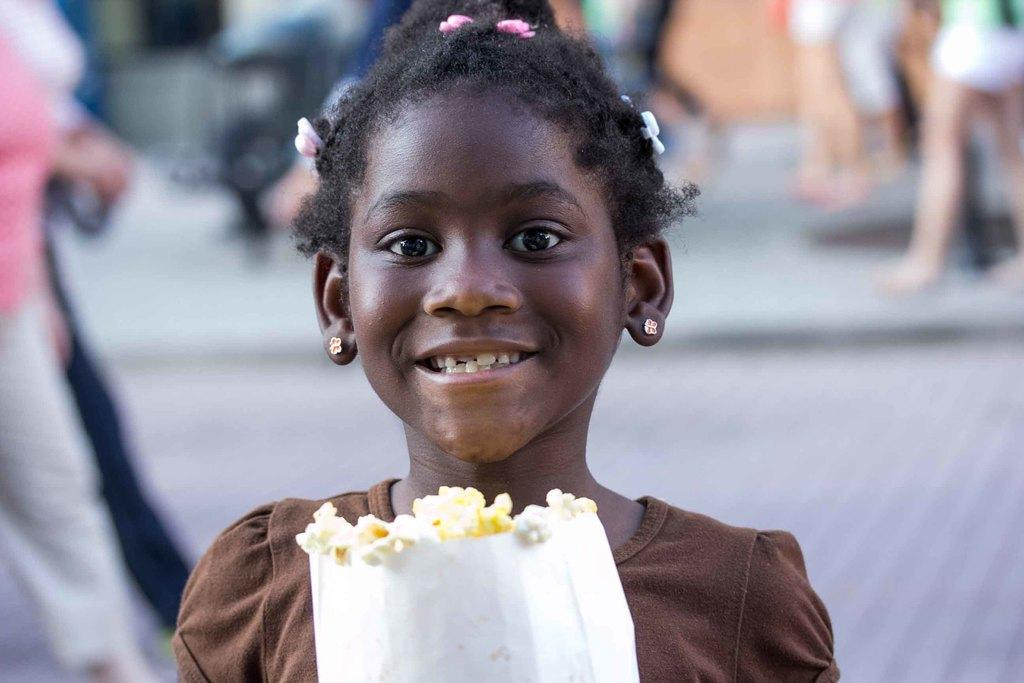What is the main subject of the image? The main subject of the image is a girl standing in the middle. What is the girl doing in the image? The girl is smiling and holding popcorn. What can be seen in the background of the image? There are people walking in the background of the image. How would you describe the background of the image? The background of the image is blurred. What type of bread can be seen being stitched by the girl in the image? There is no bread or stitching activity present in the image. The girl is holding popcorn and smiling. 